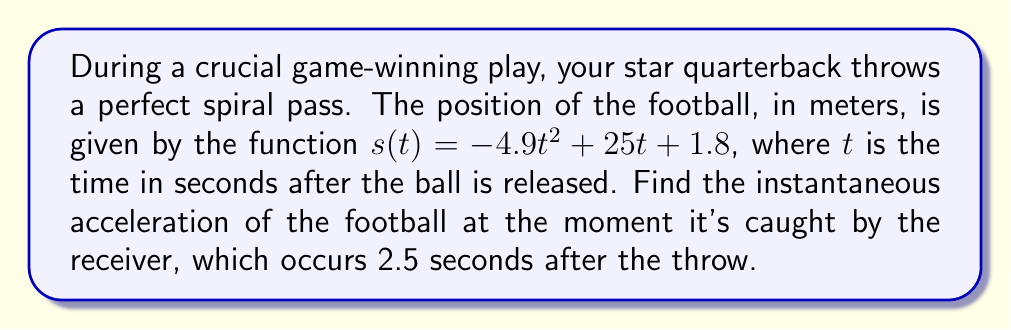Can you solve this math problem? To find the instantaneous acceleration, we need to take the second derivative of the position function.

Step 1: Find the velocity function (first derivative)
The velocity function $v(t)$ is the first derivative of the position function $s(t)$.
$$v(t) = s'(t) = \frac{d}{dt}(-4.9t^2 + 25t + 1.8)$$
$$v(t) = -9.8t + 25$$

Step 2: Find the acceleration function (second derivative)
The acceleration function $a(t)$ is the first derivative of the velocity function $v(t)$, or the second derivative of the position function $s(t)$.
$$a(t) = v'(t) = s''(t) = \frac{d}{dt}(-9.8t + 25)$$
$$a(t) = -9.8$$

Step 3: Evaluate the acceleration function at the point of catch
The football is caught at $t = 2.5$ seconds. However, since the acceleration is constant, we don't need to substitute this value.

The instantaneous acceleration at any point, including the point of catch, is $-9.8$ m/s².

Note: The negative sign indicates that the acceleration is downward, which is consistent with the acceleration due to gravity on Earth.
Answer: $-9.8$ m/s² 